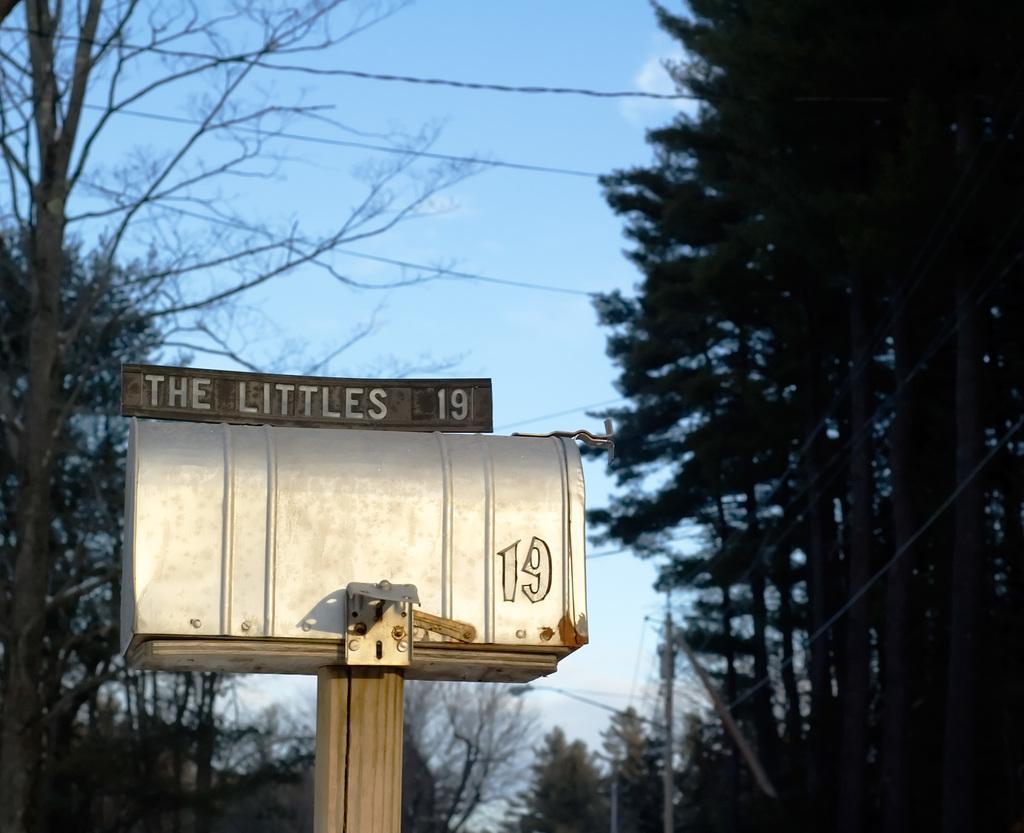Could you give a brief overview of what you see in this image? Here I can see a metal box which is placed on a wooden pole. On this box there is a metal board with some text. In the background there are many trees. At the top of the image I can see the sky in blue color. 